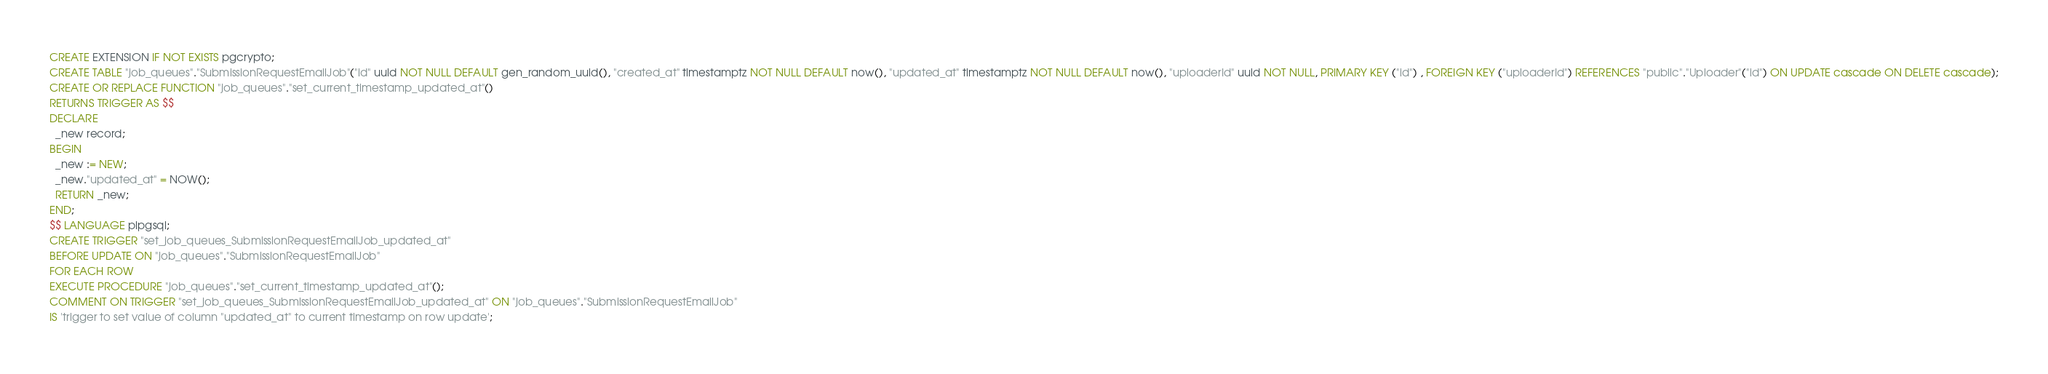Convert code to text. <code><loc_0><loc_0><loc_500><loc_500><_SQL_>CREATE EXTENSION IF NOT EXISTS pgcrypto;
CREATE TABLE "job_queues"."SubmissionRequestEmailJob"("id" uuid NOT NULL DEFAULT gen_random_uuid(), "created_at" timestamptz NOT NULL DEFAULT now(), "updated_at" timestamptz NOT NULL DEFAULT now(), "uploaderId" uuid NOT NULL, PRIMARY KEY ("id") , FOREIGN KEY ("uploaderId") REFERENCES "public"."Uploader"("id") ON UPDATE cascade ON DELETE cascade);
CREATE OR REPLACE FUNCTION "job_queues"."set_current_timestamp_updated_at"()
RETURNS TRIGGER AS $$
DECLARE
  _new record;
BEGIN
  _new := NEW;
  _new."updated_at" = NOW();
  RETURN _new;
END;
$$ LANGUAGE plpgsql;
CREATE TRIGGER "set_job_queues_SubmissionRequestEmailJob_updated_at"
BEFORE UPDATE ON "job_queues"."SubmissionRequestEmailJob"
FOR EACH ROW
EXECUTE PROCEDURE "job_queues"."set_current_timestamp_updated_at"();
COMMENT ON TRIGGER "set_job_queues_SubmissionRequestEmailJob_updated_at" ON "job_queues"."SubmissionRequestEmailJob" 
IS 'trigger to set value of column "updated_at" to current timestamp on row update';
</code> 